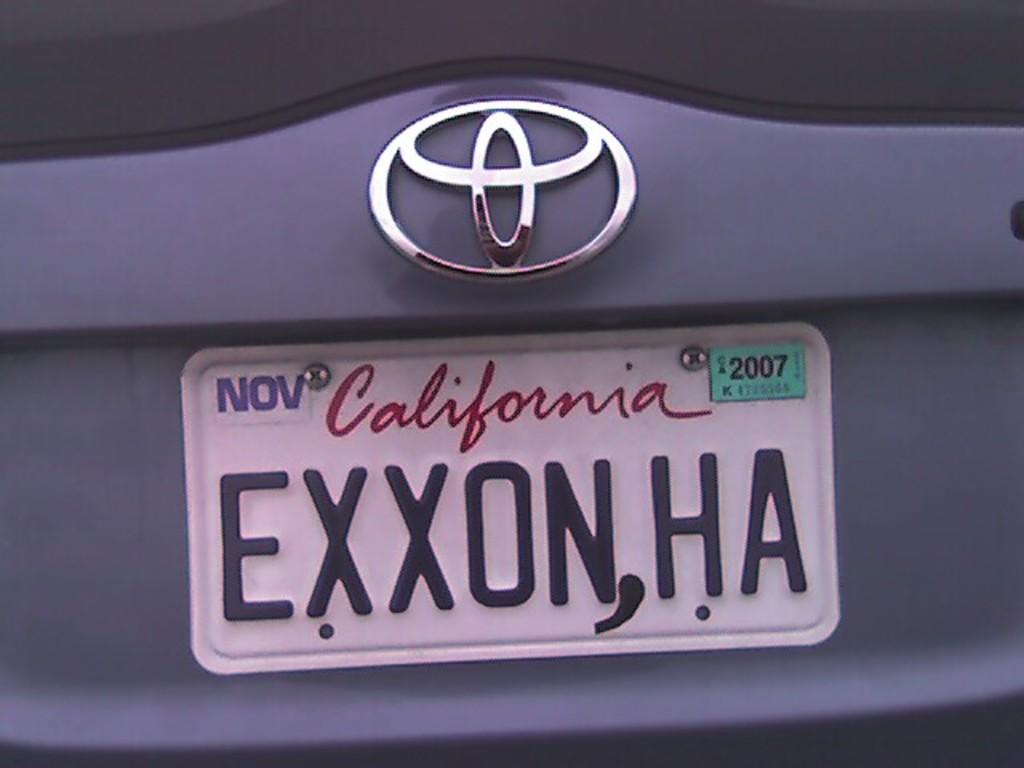When does the registration expire?
Your answer should be very brief. 2007. 